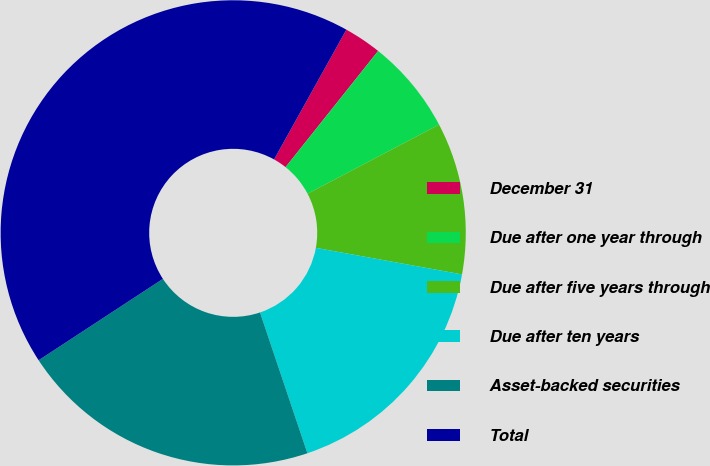<chart> <loc_0><loc_0><loc_500><loc_500><pie_chart><fcel>December 31<fcel>Due after one year through<fcel>Due after five years through<fcel>Due after ten years<fcel>Asset-backed securities<fcel>Total<nl><fcel>2.62%<fcel>6.59%<fcel>10.56%<fcel>16.97%<fcel>20.94%<fcel>42.31%<nl></chart> 